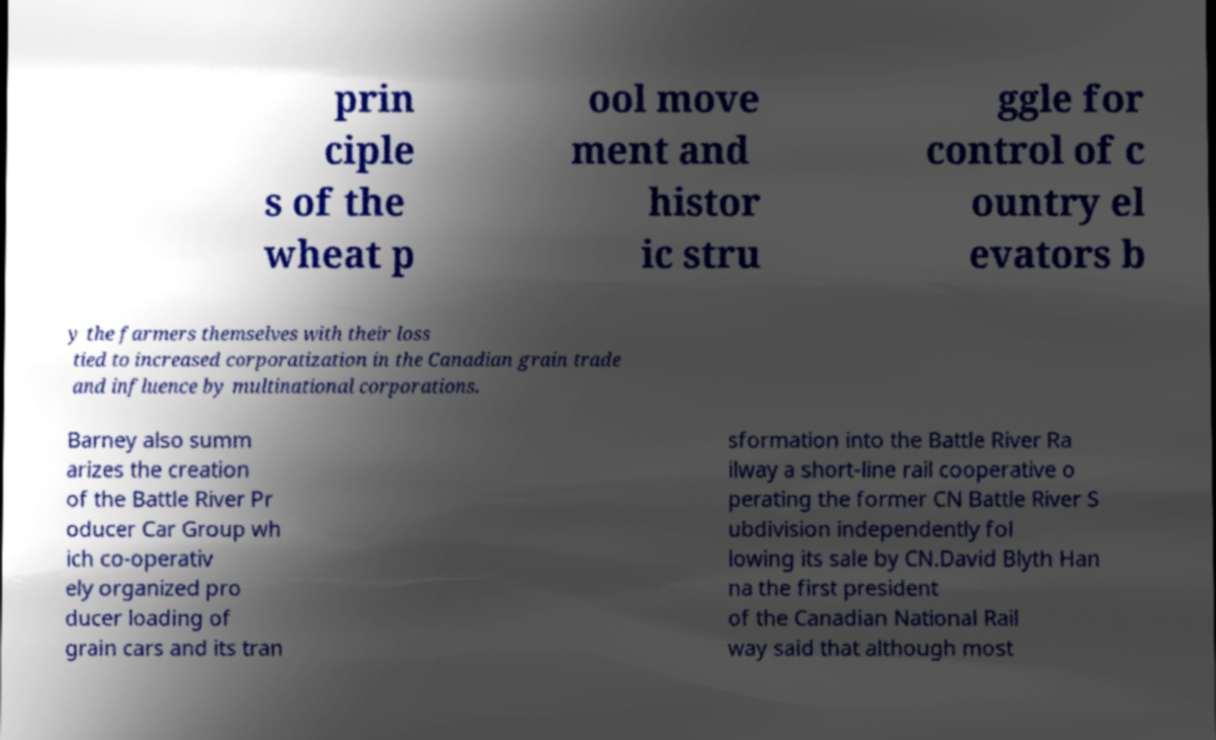I need the written content from this picture converted into text. Can you do that? prin ciple s of the wheat p ool move ment and histor ic stru ggle for control of c ountry el evators b y the farmers themselves with their loss tied to increased corporatization in the Canadian grain trade and influence by multinational corporations. Barney also summ arizes the creation of the Battle River Pr oducer Car Group wh ich co-operativ ely organized pro ducer loading of grain cars and its tran sformation into the Battle River Ra ilway a short-line rail cooperative o perating the former CN Battle River S ubdivision independently fol lowing its sale by CN.David Blyth Han na the first president of the Canadian National Rail way said that although most 